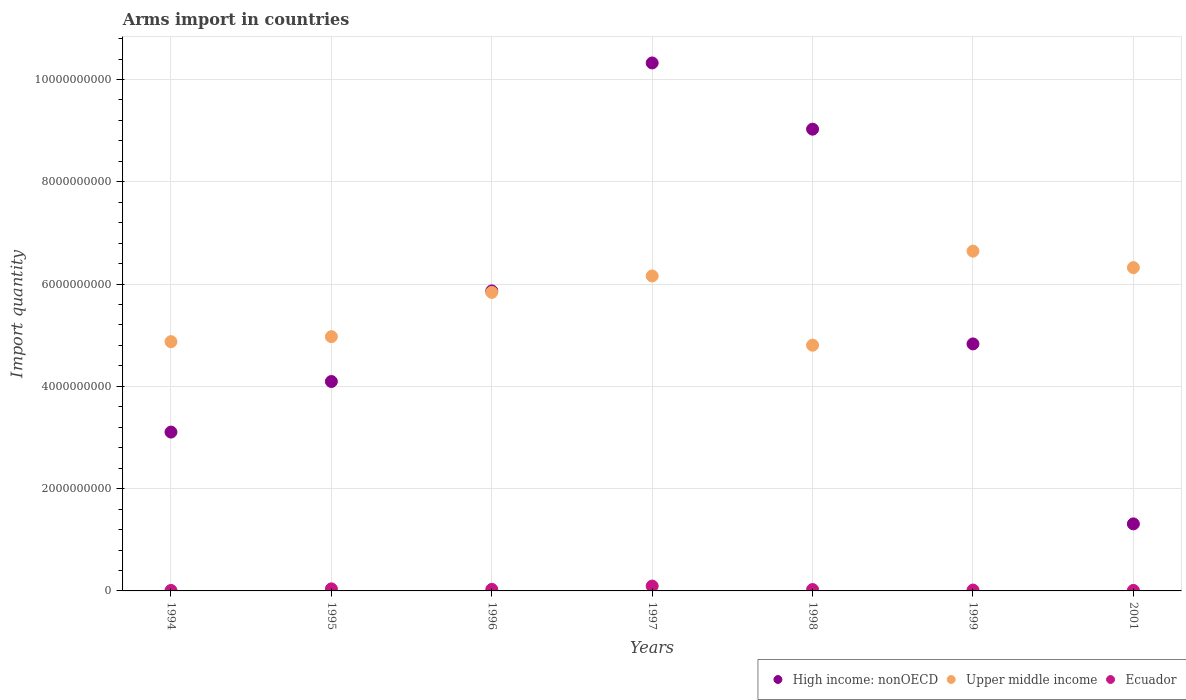How many different coloured dotlines are there?
Offer a terse response. 3. Is the number of dotlines equal to the number of legend labels?
Provide a succinct answer. Yes. What is the total arms import in Upper middle income in 1995?
Ensure brevity in your answer.  4.97e+09. Across all years, what is the maximum total arms import in Upper middle income?
Your response must be concise. 6.64e+09. Across all years, what is the minimum total arms import in High income: nonOECD?
Your answer should be very brief. 1.31e+09. In which year was the total arms import in Upper middle income maximum?
Your response must be concise. 1999. What is the total total arms import in Ecuador in the graph?
Your response must be concise. 2.28e+08. What is the difference between the total arms import in High income: nonOECD in 1998 and that in 1999?
Make the answer very short. 4.20e+09. What is the difference between the total arms import in Upper middle income in 1994 and the total arms import in High income: nonOECD in 1995?
Ensure brevity in your answer.  7.79e+08. What is the average total arms import in Ecuador per year?
Offer a terse response. 3.26e+07. In the year 1998, what is the difference between the total arms import in High income: nonOECD and total arms import in Ecuador?
Provide a succinct answer. 9.00e+09. What is the ratio of the total arms import in Upper middle income in 1994 to that in 1997?
Give a very brief answer. 0.79. Is the difference between the total arms import in High income: nonOECD in 1996 and 1997 greater than the difference between the total arms import in Ecuador in 1996 and 1997?
Provide a succinct answer. No. What is the difference between the highest and the second highest total arms import in Ecuador?
Make the answer very short. 5.50e+07. What is the difference between the highest and the lowest total arms import in Upper middle income?
Give a very brief answer. 1.84e+09. Is the sum of the total arms import in High income: nonOECD in 1997 and 1999 greater than the maximum total arms import in Ecuador across all years?
Keep it short and to the point. Yes. Does the total arms import in Ecuador monotonically increase over the years?
Your answer should be compact. No. Is the total arms import in Ecuador strictly less than the total arms import in High income: nonOECD over the years?
Provide a succinct answer. Yes. How many dotlines are there?
Offer a terse response. 3. Are the values on the major ticks of Y-axis written in scientific E-notation?
Ensure brevity in your answer.  No. Does the graph contain grids?
Make the answer very short. Yes. How many legend labels are there?
Give a very brief answer. 3. How are the legend labels stacked?
Give a very brief answer. Horizontal. What is the title of the graph?
Ensure brevity in your answer.  Arms import in countries. Does "Uruguay" appear as one of the legend labels in the graph?
Ensure brevity in your answer.  No. What is the label or title of the X-axis?
Your answer should be compact. Years. What is the label or title of the Y-axis?
Provide a short and direct response. Import quantity. What is the Import quantity of High income: nonOECD in 1994?
Offer a very short reply. 3.11e+09. What is the Import quantity of Upper middle income in 1994?
Offer a terse response. 4.87e+09. What is the Import quantity in Ecuador in 1994?
Ensure brevity in your answer.  9.00e+06. What is the Import quantity in High income: nonOECD in 1995?
Keep it short and to the point. 4.10e+09. What is the Import quantity in Upper middle income in 1995?
Provide a short and direct response. 4.97e+09. What is the Import quantity in Ecuador in 1995?
Provide a succinct answer. 4.00e+07. What is the Import quantity of High income: nonOECD in 1996?
Offer a very short reply. 5.87e+09. What is the Import quantity in Upper middle income in 1996?
Your answer should be compact. 5.84e+09. What is the Import quantity of Ecuador in 1996?
Keep it short and to the point. 3.00e+07. What is the Import quantity of High income: nonOECD in 1997?
Your answer should be very brief. 1.03e+1. What is the Import quantity in Upper middle income in 1997?
Offer a very short reply. 6.16e+09. What is the Import quantity in Ecuador in 1997?
Provide a succinct answer. 9.50e+07. What is the Import quantity of High income: nonOECD in 1998?
Your answer should be compact. 9.03e+09. What is the Import quantity of Upper middle income in 1998?
Ensure brevity in your answer.  4.80e+09. What is the Import quantity in Ecuador in 1998?
Offer a terse response. 2.70e+07. What is the Import quantity of High income: nonOECD in 1999?
Make the answer very short. 4.83e+09. What is the Import quantity of Upper middle income in 1999?
Make the answer very short. 6.64e+09. What is the Import quantity of Ecuador in 1999?
Provide a succinct answer. 1.70e+07. What is the Import quantity of High income: nonOECD in 2001?
Provide a succinct answer. 1.31e+09. What is the Import quantity of Upper middle income in 2001?
Your answer should be compact. 6.32e+09. What is the Import quantity in Ecuador in 2001?
Provide a short and direct response. 1.00e+07. Across all years, what is the maximum Import quantity in High income: nonOECD?
Offer a terse response. 1.03e+1. Across all years, what is the maximum Import quantity of Upper middle income?
Your response must be concise. 6.64e+09. Across all years, what is the maximum Import quantity in Ecuador?
Provide a succinct answer. 9.50e+07. Across all years, what is the minimum Import quantity in High income: nonOECD?
Keep it short and to the point. 1.31e+09. Across all years, what is the minimum Import quantity in Upper middle income?
Keep it short and to the point. 4.80e+09. Across all years, what is the minimum Import quantity in Ecuador?
Your answer should be compact. 9.00e+06. What is the total Import quantity of High income: nonOECD in the graph?
Your answer should be very brief. 3.86e+1. What is the total Import quantity of Upper middle income in the graph?
Keep it short and to the point. 3.96e+1. What is the total Import quantity of Ecuador in the graph?
Your response must be concise. 2.28e+08. What is the difference between the Import quantity of High income: nonOECD in 1994 and that in 1995?
Your answer should be very brief. -9.89e+08. What is the difference between the Import quantity in Upper middle income in 1994 and that in 1995?
Keep it short and to the point. -9.80e+07. What is the difference between the Import quantity of Ecuador in 1994 and that in 1995?
Your response must be concise. -3.10e+07. What is the difference between the Import quantity of High income: nonOECD in 1994 and that in 1996?
Provide a succinct answer. -2.76e+09. What is the difference between the Import quantity of Upper middle income in 1994 and that in 1996?
Provide a short and direct response. -9.64e+08. What is the difference between the Import quantity of Ecuador in 1994 and that in 1996?
Your answer should be very brief. -2.10e+07. What is the difference between the Import quantity in High income: nonOECD in 1994 and that in 1997?
Keep it short and to the point. -7.22e+09. What is the difference between the Import quantity in Upper middle income in 1994 and that in 1997?
Offer a very short reply. -1.28e+09. What is the difference between the Import quantity in Ecuador in 1994 and that in 1997?
Provide a short and direct response. -8.60e+07. What is the difference between the Import quantity in High income: nonOECD in 1994 and that in 1998?
Make the answer very short. -5.92e+09. What is the difference between the Import quantity of Upper middle income in 1994 and that in 1998?
Provide a short and direct response. 6.90e+07. What is the difference between the Import quantity in Ecuador in 1994 and that in 1998?
Make the answer very short. -1.80e+07. What is the difference between the Import quantity of High income: nonOECD in 1994 and that in 1999?
Keep it short and to the point. -1.72e+09. What is the difference between the Import quantity of Upper middle income in 1994 and that in 1999?
Make the answer very short. -1.77e+09. What is the difference between the Import quantity in Ecuador in 1994 and that in 1999?
Your response must be concise. -8.00e+06. What is the difference between the Import quantity of High income: nonOECD in 1994 and that in 2001?
Keep it short and to the point. 1.80e+09. What is the difference between the Import quantity of Upper middle income in 1994 and that in 2001?
Make the answer very short. -1.45e+09. What is the difference between the Import quantity in High income: nonOECD in 1995 and that in 1996?
Provide a succinct answer. -1.77e+09. What is the difference between the Import quantity in Upper middle income in 1995 and that in 1996?
Your answer should be very brief. -8.66e+08. What is the difference between the Import quantity in High income: nonOECD in 1995 and that in 1997?
Offer a terse response. -6.23e+09. What is the difference between the Import quantity of Upper middle income in 1995 and that in 1997?
Ensure brevity in your answer.  -1.19e+09. What is the difference between the Import quantity in Ecuador in 1995 and that in 1997?
Make the answer very short. -5.50e+07. What is the difference between the Import quantity of High income: nonOECD in 1995 and that in 1998?
Provide a succinct answer. -4.93e+09. What is the difference between the Import quantity in Upper middle income in 1995 and that in 1998?
Ensure brevity in your answer.  1.67e+08. What is the difference between the Import quantity of Ecuador in 1995 and that in 1998?
Keep it short and to the point. 1.30e+07. What is the difference between the Import quantity of High income: nonOECD in 1995 and that in 1999?
Make the answer very short. -7.35e+08. What is the difference between the Import quantity of Upper middle income in 1995 and that in 1999?
Provide a short and direct response. -1.67e+09. What is the difference between the Import quantity in Ecuador in 1995 and that in 1999?
Offer a very short reply. 2.30e+07. What is the difference between the Import quantity of High income: nonOECD in 1995 and that in 2001?
Make the answer very short. 2.78e+09. What is the difference between the Import quantity of Upper middle income in 1995 and that in 2001?
Keep it short and to the point. -1.35e+09. What is the difference between the Import quantity in Ecuador in 1995 and that in 2001?
Make the answer very short. 3.00e+07. What is the difference between the Import quantity in High income: nonOECD in 1996 and that in 1997?
Your answer should be compact. -4.46e+09. What is the difference between the Import quantity of Upper middle income in 1996 and that in 1997?
Your response must be concise. -3.21e+08. What is the difference between the Import quantity of Ecuador in 1996 and that in 1997?
Your response must be concise. -6.50e+07. What is the difference between the Import quantity in High income: nonOECD in 1996 and that in 1998?
Give a very brief answer. -3.16e+09. What is the difference between the Import quantity of Upper middle income in 1996 and that in 1998?
Your answer should be compact. 1.03e+09. What is the difference between the Import quantity in High income: nonOECD in 1996 and that in 1999?
Your answer should be very brief. 1.04e+09. What is the difference between the Import quantity in Upper middle income in 1996 and that in 1999?
Make the answer very short. -8.06e+08. What is the difference between the Import quantity in Ecuador in 1996 and that in 1999?
Give a very brief answer. 1.30e+07. What is the difference between the Import quantity in High income: nonOECD in 1996 and that in 2001?
Your answer should be compact. 4.56e+09. What is the difference between the Import quantity of Upper middle income in 1996 and that in 2001?
Your answer should be compact. -4.84e+08. What is the difference between the Import quantity in Ecuador in 1996 and that in 2001?
Make the answer very short. 2.00e+07. What is the difference between the Import quantity of High income: nonOECD in 1997 and that in 1998?
Ensure brevity in your answer.  1.30e+09. What is the difference between the Import quantity of Upper middle income in 1997 and that in 1998?
Keep it short and to the point. 1.35e+09. What is the difference between the Import quantity in Ecuador in 1997 and that in 1998?
Your answer should be very brief. 6.80e+07. What is the difference between the Import quantity of High income: nonOECD in 1997 and that in 1999?
Provide a succinct answer. 5.49e+09. What is the difference between the Import quantity in Upper middle income in 1997 and that in 1999?
Your response must be concise. -4.85e+08. What is the difference between the Import quantity of Ecuador in 1997 and that in 1999?
Your answer should be very brief. 7.80e+07. What is the difference between the Import quantity of High income: nonOECD in 1997 and that in 2001?
Offer a terse response. 9.01e+09. What is the difference between the Import quantity of Upper middle income in 1997 and that in 2001?
Make the answer very short. -1.63e+08. What is the difference between the Import quantity of Ecuador in 1997 and that in 2001?
Give a very brief answer. 8.50e+07. What is the difference between the Import quantity of High income: nonOECD in 1998 and that in 1999?
Offer a very short reply. 4.20e+09. What is the difference between the Import quantity in Upper middle income in 1998 and that in 1999?
Your answer should be very brief. -1.84e+09. What is the difference between the Import quantity in Ecuador in 1998 and that in 1999?
Your answer should be very brief. 1.00e+07. What is the difference between the Import quantity of High income: nonOECD in 1998 and that in 2001?
Your answer should be very brief. 7.72e+09. What is the difference between the Import quantity in Upper middle income in 1998 and that in 2001?
Make the answer very short. -1.52e+09. What is the difference between the Import quantity of Ecuador in 1998 and that in 2001?
Provide a short and direct response. 1.70e+07. What is the difference between the Import quantity in High income: nonOECD in 1999 and that in 2001?
Offer a terse response. 3.52e+09. What is the difference between the Import quantity in Upper middle income in 1999 and that in 2001?
Give a very brief answer. 3.22e+08. What is the difference between the Import quantity of Ecuador in 1999 and that in 2001?
Ensure brevity in your answer.  7.00e+06. What is the difference between the Import quantity of High income: nonOECD in 1994 and the Import quantity of Upper middle income in 1995?
Your response must be concise. -1.87e+09. What is the difference between the Import quantity in High income: nonOECD in 1994 and the Import quantity in Ecuador in 1995?
Offer a terse response. 3.07e+09. What is the difference between the Import quantity in Upper middle income in 1994 and the Import quantity in Ecuador in 1995?
Keep it short and to the point. 4.83e+09. What is the difference between the Import quantity in High income: nonOECD in 1994 and the Import quantity in Upper middle income in 1996?
Give a very brief answer. -2.73e+09. What is the difference between the Import quantity of High income: nonOECD in 1994 and the Import quantity of Ecuador in 1996?
Your answer should be compact. 3.08e+09. What is the difference between the Import quantity of Upper middle income in 1994 and the Import quantity of Ecuador in 1996?
Provide a short and direct response. 4.84e+09. What is the difference between the Import quantity in High income: nonOECD in 1994 and the Import quantity in Upper middle income in 1997?
Ensure brevity in your answer.  -3.05e+09. What is the difference between the Import quantity in High income: nonOECD in 1994 and the Import quantity in Ecuador in 1997?
Give a very brief answer. 3.01e+09. What is the difference between the Import quantity in Upper middle income in 1994 and the Import quantity in Ecuador in 1997?
Your answer should be compact. 4.78e+09. What is the difference between the Import quantity in High income: nonOECD in 1994 and the Import quantity in Upper middle income in 1998?
Your answer should be very brief. -1.70e+09. What is the difference between the Import quantity of High income: nonOECD in 1994 and the Import quantity of Ecuador in 1998?
Provide a succinct answer. 3.08e+09. What is the difference between the Import quantity of Upper middle income in 1994 and the Import quantity of Ecuador in 1998?
Make the answer very short. 4.85e+09. What is the difference between the Import quantity of High income: nonOECD in 1994 and the Import quantity of Upper middle income in 1999?
Offer a terse response. -3.54e+09. What is the difference between the Import quantity in High income: nonOECD in 1994 and the Import quantity in Ecuador in 1999?
Provide a succinct answer. 3.09e+09. What is the difference between the Import quantity of Upper middle income in 1994 and the Import quantity of Ecuador in 1999?
Keep it short and to the point. 4.86e+09. What is the difference between the Import quantity in High income: nonOECD in 1994 and the Import quantity in Upper middle income in 2001?
Offer a terse response. -3.22e+09. What is the difference between the Import quantity in High income: nonOECD in 1994 and the Import quantity in Ecuador in 2001?
Keep it short and to the point. 3.10e+09. What is the difference between the Import quantity of Upper middle income in 1994 and the Import quantity of Ecuador in 2001?
Your response must be concise. 4.86e+09. What is the difference between the Import quantity of High income: nonOECD in 1995 and the Import quantity of Upper middle income in 1996?
Your response must be concise. -1.74e+09. What is the difference between the Import quantity in High income: nonOECD in 1995 and the Import quantity in Ecuador in 1996?
Offer a very short reply. 4.06e+09. What is the difference between the Import quantity of Upper middle income in 1995 and the Import quantity of Ecuador in 1996?
Ensure brevity in your answer.  4.94e+09. What is the difference between the Import quantity of High income: nonOECD in 1995 and the Import quantity of Upper middle income in 1997?
Your answer should be very brief. -2.06e+09. What is the difference between the Import quantity of High income: nonOECD in 1995 and the Import quantity of Ecuador in 1997?
Ensure brevity in your answer.  4.00e+09. What is the difference between the Import quantity in Upper middle income in 1995 and the Import quantity in Ecuador in 1997?
Your answer should be very brief. 4.88e+09. What is the difference between the Import quantity of High income: nonOECD in 1995 and the Import quantity of Upper middle income in 1998?
Provide a short and direct response. -7.10e+08. What is the difference between the Import quantity in High income: nonOECD in 1995 and the Import quantity in Ecuador in 1998?
Your answer should be compact. 4.07e+09. What is the difference between the Import quantity of Upper middle income in 1995 and the Import quantity of Ecuador in 1998?
Keep it short and to the point. 4.94e+09. What is the difference between the Import quantity of High income: nonOECD in 1995 and the Import quantity of Upper middle income in 1999?
Offer a very short reply. -2.55e+09. What is the difference between the Import quantity of High income: nonOECD in 1995 and the Import quantity of Ecuador in 1999?
Your response must be concise. 4.08e+09. What is the difference between the Import quantity of Upper middle income in 1995 and the Import quantity of Ecuador in 1999?
Your response must be concise. 4.96e+09. What is the difference between the Import quantity in High income: nonOECD in 1995 and the Import quantity in Upper middle income in 2001?
Your answer should be compact. -2.23e+09. What is the difference between the Import quantity in High income: nonOECD in 1995 and the Import quantity in Ecuador in 2001?
Give a very brief answer. 4.08e+09. What is the difference between the Import quantity of Upper middle income in 1995 and the Import quantity of Ecuador in 2001?
Make the answer very short. 4.96e+09. What is the difference between the Import quantity in High income: nonOECD in 1996 and the Import quantity in Upper middle income in 1997?
Your answer should be very brief. -2.93e+08. What is the difference between the Import quantity in High income: nonOECD in 1996 and the Import quantity in Ecuador in 1997?
Offer a terse response. 5.77e+09. What is the difference between the Import quantity of Upper middle income in 1996 and the Import quantity of Ecuador in 1997?
Your answer should be very brief. 5.74e+09. What is the difference between the Import quantity of High income: nonOECD in 1996 and the Import quantity of Upper middle income in 1998?
Make the answer very short. 1.06e+09. What is the difference between the Import quantity of High income: nonOECD in 1996 and the Import quantity of Ecuador in 1998?
Keep it short and to the point. 5.84e+09. What is the difference between the Import quantity in Upper middle income in 1996 and the Import quantity in Ecuador in 1998?
Ensure brevity in your answer.  5.81e+09. What is the difference between the Import quantity of High income: nonOECD in 1996 and the Import quantity of Upper middle income in 1999?
Your response must be concise. -7.78e+08. What is the difference between the Import quantity of High income: nonOECD in 1996 and the Import quantity of Ecuador in 1999?
Your answer should be very brief. 5.85e+09. What is the difference between the Import quantity of Upper middle income in 1996 and the Import quantity of Ecuador in 1999?
Ensure brevity in your answer.  5.82e+09. What is the difference between the Import quantity in High income: nonOECD in 1996 and the Import quantity in Upper middle income in 2001?
Offer a terse response. -4.56e+08. What is the difference between the Import quantity in High income: nonOECD in 1996 and the Import quantity in Ecuador in 2001?
Offer a terse response. 5.86e+09. What is the difference between the Import quantity of Upper middle income in 1996 and the Import quantity of Ecuador in 2001?
Offer a very short reply. 5.83e+09. What is the difference between the Import quantity in High income: nonOECD in 1997 and the Import quantity in Upper middle income in 1998?
Ensure brevity in your answer.  5.52e+09. What is the difference between the Import quantity in High income: nonOECD in 1997 and the Import quantity in Ecuador in 1998?
Your answer should be compact. 1.03e+1. What is the difference between the Import quantity in Upper middle income in 1997 and the Import quantity in Ecuador in 1998?
Ensure brevity in your answer.  6.13e+09. What is the difference between the Import quantity in High income: nonOECD in 1997 and the Import quantity in Upper middle income in 1999?
Your response must be concise. 3.68e+09. What is the difference between the Import quantity of High income: nonOECD in 1997 and the Import quantity of Ecuador in 1999?
Make the answer very short. 1.03e+1. What is the difference between the Import quantity in Upper middle income in 1997 and the Import quantity in Ecuador in 1999?
Give a very brief answer. 6.14e+09. What is the difference between the Import quantity of High income: nonOECD in 1997 and the Import quantity of Upper middle income in 2001?
Your answer should be compact. 4.00e+09. What is the difference between the Import quantity of High income: nonOECD in 1997 and the Import quantity of Ecuador in 2001?
Give a very brief answer. 1.03e+1. What is the difference between the Import quantity in Upper middle income in 1997 and the Import quantity in Ecuador in 2001?
Offer a very short reply. 6.15e+09. What is the difference between the Import quantity of High income: nonOECD in 1998 and the Import quantity of Upper middle income in 1999?
Your answer should be compact. 2.38e+09. What is the difference between the Import quantity of High income: nonOECD in 1998 and the Import quantity of Ecuador in 1999?
Keep it short and to the point. 9.01e+09. What is the difference between the Import quantity in Upper middle income in 1998 and the Import quantity in Ecuador in 1999?
Make the answer very short. 4.79e+09. What is the difference between the Import quantity in High income: nonOECD in 1998 and the Import quantity in Upper middle income in 2001?
Your answer should be very brief. 2.71e+09. What is the difference between the Import quantity in High income: nonOECD in 1998 and the Import quantity in Ecuador in 2001?
Offer a very short reply. 9.02e+09. What is the difference between the Import quantity in Upper middle income in 1998 and the Import quantity in Ecuador in 2001?
Keep it short and to the point. 4.80e+09. What is the difference between the Import quantity of High income: nonOECD in 1999 and the Import quantity of Upper middle income in 2001?
Provide a short and direct response. -1.49e+09. What is the difference between the Import quantity of High income: nonOECD in 1999 and the Import quantity of Ecuador in 2001?
Your response must be concise. 4.82e+09. What is the difference between the Import quantity in Upper middle income in 1999 and the Import quantity in Ecuador in 2001?
Provide a short and direct response. 6.63e+09. What is the average Import quantity in High income: nonOECD per year?
Provide a short and direct response. 5.51e+09. What is the average Import quantity of Upper middle income per year?
Ensure brevity in your answer.  5.66e+09. What is the average Import quantity in Ecuador per year?
Ensure brevity in your answer.  3.26e+07. In the year 1994, what is the difference between the Import quantity in High income: nonOECD and Import quantity in Upper middle income?
Offer a very short reply. -1.77e+09. In the year 1994, what is the difference between the Import quantity of High income: nonOECD and Import quantity of Ecuador?
Ensure brevity in your answer.  3.10e+09. In the year 1994, what is the difference between the Import quantity of Upper middle income and Import quantity of Ecuador?
Offer a terse response. 4.86e+09. In the year 1995, what is the difference between the Import quantity in High income: nonOECD and Import quantity in Upper middle income?
Provide a short and direct response. -8.77e+08. In the year 1995, what is the difference between the Import quantity in High income: nonOECD and Import quantity in Ecuador?
Offer a terse response. 4.06e+09. In the year 1995, what is the difference between the Import quantity in Upper middle income and Import quantity in Ecuador?
Give a very brief answer. 4.93e+09. In the year 1996, what is the difference between the Import quantity of High income: nonOECD and Import quantity of Upper middle income?
Offer a very short reply. 2.80e+07. In the year 1996, what is the difference between the Import quantity in High income: nonOECD and Import quantity in Ecuador?
Offer a very short reply. 5.84e+09. In the year 1996, what is the difference between the Import quantity in Upper middle income and Import quantity in Ecuador?
Provide a short and direct response. 5.81e+09. In the year 1997, what is the difference between the Import quantity of High income: nonOECD and Import quantity of Upper middle income?
Provide a succinct answer. 4.16e+09. In the year 1997, what is the difference between the Import quantity in High income: nonOECD and Import quantity in Ecuador?
Offer a terse response. 1.02e+1. In the year 1997, what is the difference between the Import quantity of Upper middle income and Import quantity of Ecuador?
Your answer should be very brief. 6.06e+09. In the year 1998, what is the difference between the Import quantity in High income: nonOECD and Import quantity in Upper middle income?
Provide a short and direct response. 4.22e+09. In the year 1998, what is the difference between the Import quantity in High income: nonOECD and Import quantity in Ecuador?
Your answer should be very brief. 9.00e+09. In the year 1998, what is the difference between the Import quantity of Upper middle income and Import quantity of Ecuador?
Your answer should be very brief. 4.78e+09. In the year 1999, what is the difference between the Import quantity of High income: nonOECD and Import quantity of Upper middle income?
Your answer should be very brief. -1.81e+09. In the year 1999, what is the difference between the Import quantity in High income: nonOECD and Import quantity in Ecuador?
Keep it short and to the point. 4.81e+09. In the year 1999, what is the difference between the Import quantity of Upper middle income and Import quantity of Ecuador?
Your answer should be very brief. 6.63e+09. In the year 2001, what is the difference between the Import quantity in High income: nonOECD and Import quantity in Upper middle income?
Provide a short and direct response. -5.01e+09. In the year 2001, what is the difference between the Import quantity of High income: nonOECD and Import quantity of Ecuador?
Your answer should be very brief. 1.30e+09. In the year 2001, what is the difference between the Import quantity of Upper middle income and Import quantity of Ecuador?
Your answer should be very brief. 6.31e+09. What is the ratio of the Import quantity in High income: nonOECD in 1994 to that in 1995?
Your response must be concise. 0.76. What is the ratio of the Import quantity of Upper middle income in 1994 to that in 1995?
Keep it short and to the point. 0.98. What is the ratio of the Import quantity in Ecuador in 1994 to that in 1995?
Provide a succinct answer. 0.23. What is the ratio of the Import quantity in High income: nonOECD in 1994 to that in 1996?
Make the answer very short. 0.53. What is the ratio of the Import quantity of Upper middle income in 1994 to that in 1996?
Provide a short and direct response. 0.83. What is the ratio of the Import quantity of High income: nonOECD in 1994 to that in 1997?
Your answer should be compact. 0.3. What is the ratio of the Import quantity of Upper middle income in 1994 to that in 1997?
Your answer should be very brief. 0.79. What is the ratio of the Import quantity in Ecuador in 1994 to that in 1997?
Keep it short and to the point. 0.09. What is the ratio of the Import quantity of High income: nonOECD in 1994 to that in 1998?
Provide a succinct answer. 0.34. What is the ratio of the Import quantity of Upper middle income in 1994 to that in 1998?
Provide a short and direct response. 1.01. What is the ratio of the Import quantity of Ecuador in 1994 to that in 1998?
Offer a very short reply. 0.33. What is the ratio of the Import quantity of High income: nonOECD in 1994 to that in 1999?
Ensure brevity in your answer.  0.64. What is the ratio of the Import quantity of Upper middle income in 1994 to that in 1999?
Give a very brief answer. 0.73. What is the ratio of the Import quantity in Ecuador in 1994 to that in 1999?
Your response must be concise. 0.53. What is the ratio of the Import quantity in High income: nonOECD in 1994 to that in 2001?
Provide a succinct answer. 2.37. What is the ratio of the Import quantity of Upper middle income in 1994 to that in 2001?
Your answer should be compact. 0.77. What is the ratio of the Import quantity of High income: nonOECD in 1995 to that in 1996?
Your answer should be compact. 0.7. What is the ratio of the Import quantity in Upper middle income in 1995 to that in 1996?
Make the answer very short. 0.85. What is the ratio of the Import quantity in High income: nonOECD in 1995 to that in 1997?
Provide a succinct answer. 0.4. What is the ratio of the Import quantity in Upper middle income in 1995 to that in 1997?
Keep it short and to the point. 0.81. What is the ratio of the Import quantity of Ecuador in 1995 to that in 1997?
Your answer should be compact. 0.42. What is the ratio of the Import quantity of High income: nonOECD in 1995 to that in 1998?
Provide a succinct answer. 0.45. What is the ratio of the Import quantity in Upper middle income in 1995 to that in 1998?
Offer a very short reply. 1.03. What is the ratio of the Import quantity in Ecuador in 1995 to that in 1998?
Keep it short and to the point. 1.48. What is the ratio of the Import quantity in High income: nonOECD in 1995 to that in 1999?
Your answer should be compact. 0.85. What is the ratio of the Import quantity of Upper middle income in 1995 to that in 1999?
Your response must be concise. 0.75. What is the ratio of the Import quantity in Ecuador in 1995 to that in 1999?
Offer a terse response. 2.35. What is the ratio of the Import quantity in High income: nonOECD in 1995 to that in 2001?
Provide a succinct answer. 3.12. What is the ratio of the Import quantity in Upper middle income in 1995 to that in 2001?
Ensure brevity in your answer.  0.79. What is the ratio of the Import quantity in Ecuador in 1995 to that in 2001?
Provide a short and direct response. 4. What is the ratio of the Import quantity in High income: nonOECD in 1996 to that in 1997?
Provide a succinct answer. 0.57. What is the ratio of the Import quantity in Upper middle income in 1996 to that in 1997?
Your response must be concise. 0.95. What is the ratio of the Import quantity of Ecuador in 1996 to that in 1997?
Offer a terse response. 0.32. What is the ratio of the Import quantity in High income: nonOECD in 1996 to that in 1998?
Offer a terse response. 0.65. What is the ratio of the Import quantity of Upper middle income in 1996 to that in 1998?
Your response must be concise. 1.22. What is the ratio of the Import quantity of Ecuador in 1996 to that in 1998?
Make the answer very short. 1.11. What is the ratio of the Import quantity in High income: nonOECD in 1996 to that in 1999?
Provide a short and direct response. 1.21. What is the ratio of the Import quantity in Upper middle income in 1996 to that in 1999?
Provide a succinct answer. 0.88. What is the ratio of the Import quantity in Ecuador in 1996 to that in 1999?
Provide a short and direct response. 1.76. What is the ratio of the Import quantity of High income: nonOECD in 1996 to that in 2001?
Give a very brief answer. 4.47. What is the ratio of the Import quantity in Upper middle income in 1996 to that in 2001?
Make the answer very short. 0.92. What is the ratio of the Import quantity in High income: nonOECD in 1997 to that in 1998?
Provide a succinct answer. 1.14. What is the ratio of the Import quantity of Upper middle income in 1997 to that in 1998?
Keep it short and to the point. 1.28. What is the ratio of the Import quantity of Ecuador in 1997 to that in 1998?
Keep it short and to the point. 3.52. What is the ratio of the Import quantity of High income: nonOECD in 1997 to that in 1999?
Provide a succinct answer. 2.14. What is the ratio of the Import quantity of Upper middle income in 1997 to that in 1999?
Offer a very short reply. 0.93. What is the ratio of the Import quantity of Ecuador in 1997 to that in 1999?
Your response must be concise. 5.59. What is the ratio of the Import quantity in High income: nonOECD in 1997 to that in 2001?
Ensure brevity in your answer.  7.87. What is the ratio of the Import quantity of Upper middle income in 1997 to that in 2001?
Provide a short and direct response. 0.97. What is the ratio of the Import quantity of High income: nonOECD in 1998 to that in 1999?
Your answer should be compact. 1.87. What is the ratio of the Import quantity of Upper middle income in 1998 to that in 1999?
Your response must be concise. 0.72. What is the ratio of the Import quantity in Ecuador in 1998 to that in 1999?
Offer a terse response. 1.59. What is the ratio of the Import quantity in High income: nonOECD in 1998 to that in 2001?
Keep it short and to the point. 6.89. What is the ratio of the Import quantity in Upper middle income in 1998 to that in 2001?
Provide a short and direct response. 0.76. What is the ratio of the Import quantity of Ecuador in 1998 to that in 2001?
Provide a succinct answer. 2.7. What is the ratio of the Import quantity in High income: nonOECD in 1999 to that in 2001?
Provide a short and direct response. 3.68. What is the ratio of the Import quantity of Upper middle income in 1999 to that in 2001?
Your response must be concise. 1.05. What is the difference between the highest and the second highest Import quantity of High income: nonOECD?
Offer a terse response. 1.30e+09. What is the difference between the highest and the second highest Import quantity of Upper middle income?
Your answer should be compact. 3.22e+08. What is the difference between the highest and the second highest Import quantity in Ecuador?
Your response must be concise. 5.50e+07. What is the difference between the highest and the lowest Import quantity in High income: nonOECD?
Your answer should be very brief. 9.01e+09. What is the difference between the highest and the lowest Import quantity of Upper middle income?
Offer a very short reply. 1.84e+09. What is the difference between the highest and the lowest Import quantity in Ecuador?
Provide a short and direct response. 8.60e+07. 